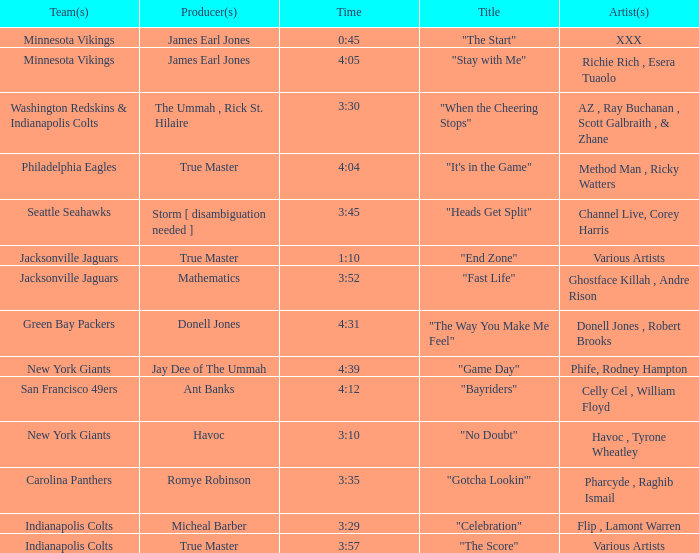Who is the artist of the New York Giants track "No Doubt"? Havoc , Tyrone Wheatley. 